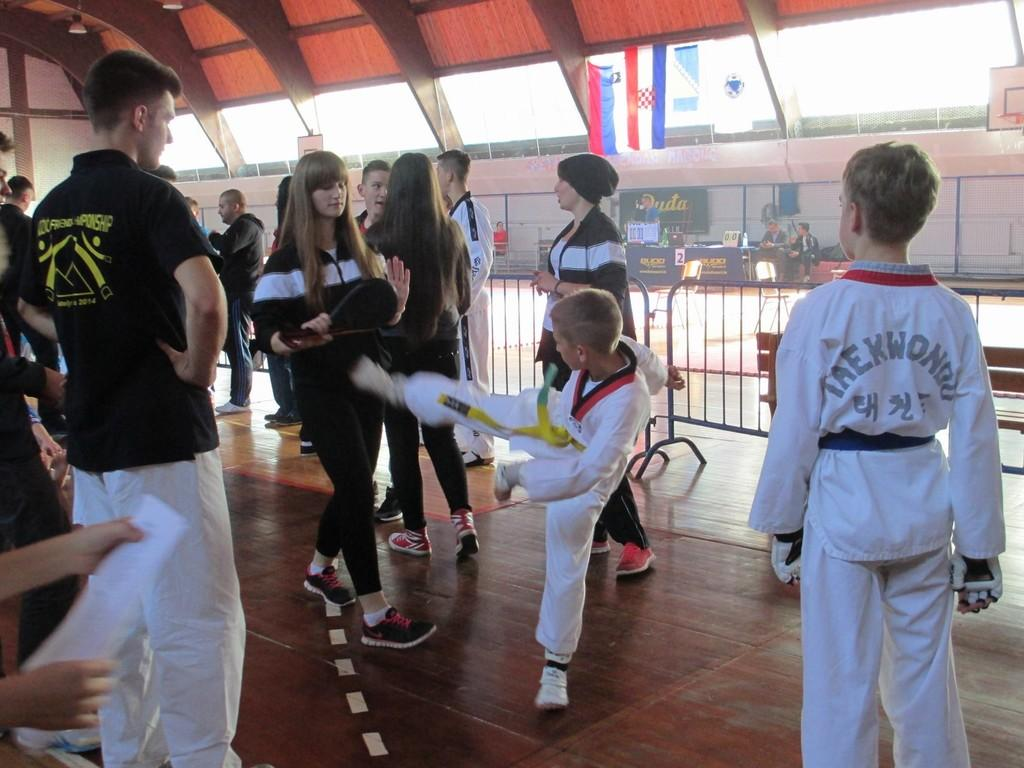<image>
Summarize the visual content of the image. A boy in a top that says taekwondo on the back watches another boy demonstrating kicks. 